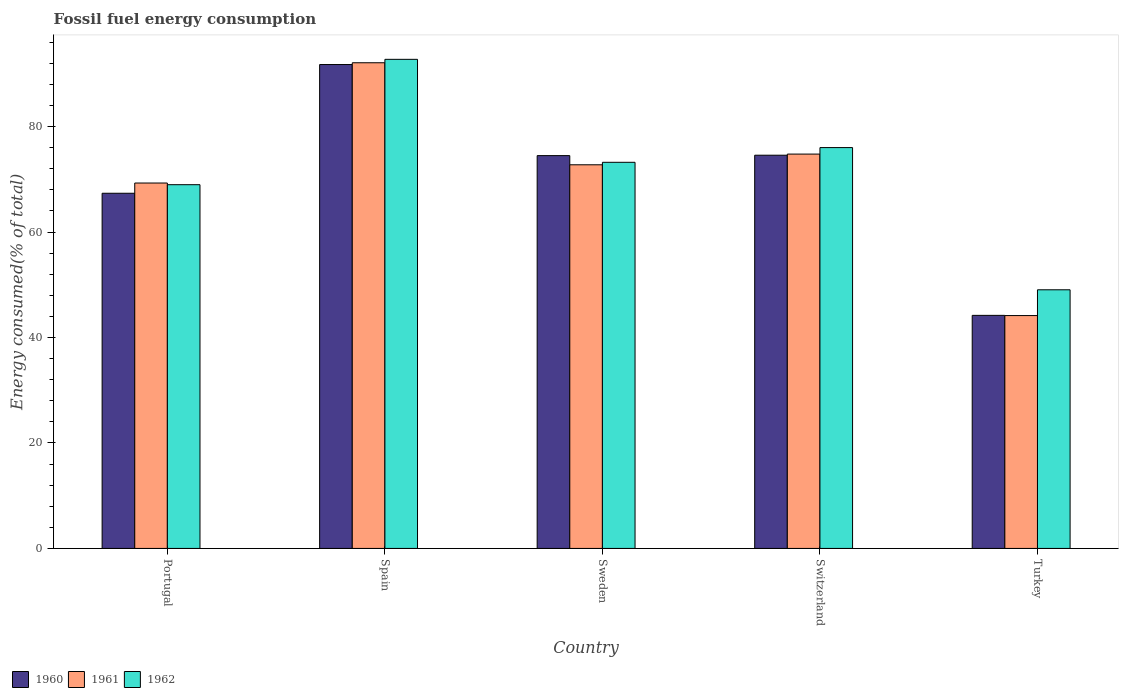Are the number of bars on each tick of the X-axis equal?
Provide a short and direct response. Yes. How many bars are there on the 4th tick from the left?
Keep it short and to the point. 3. What is the percentage of energy consumed in 1962 in Portugal?
Ensure brevity in your answer.  68.98. Across all countries, what is the maximum percentage of energy consumed in 1960?
Your answer should be compact. 91.77. Across all countries, what is the minimum percentage of energy consumed in 1960?
Offer a very short reply. 44.2. In which country was the percentage of energy consumed in 1961 maximum?
Your response must be concise. Spain. In which country was the percentage of energy consumed in 1960 minimum?
Offer a terse response. Turkey. What is the total percentage of energy consumed in 1961 in the graph?
Offer a very short reply. 353.1. What is the difference between the percentage of energy consumed in 1961 in Portugal and that in Spain?
Your answer should be compact. -22.81. What is the difference between the percentage of energy consumed in 1962 in Portugal and the percentage of energy consumed in 1960 in Turkey?
Ensure brevity in your answer.  24.78. What is the average percentage of energy consumed in 1960 per country?
Provide a short and direct response. 70.48. What is the difference between the percentage of energy consumed of/in 1961 and percentage of energy consumed of/in 1960 in Turkey?
Offer a very short reply. -0.04. What is the ratio of the percentage of energy consumed in 1962 in Spain to that in Turkey?
Make the answer very short. 1.89. Is the percentage of energy consumed in 1962 in Portugal less than that in Sweden?
Offer a very short reply. Yes. Is the difference between the percentage of energy consumed in 1961 in Portugal and Turkey greater than the difference between the percentage of energy consumed in 1960 in Portugal and Turkey?
Offer a very short reply. Yes. What is the difference between the highest and the second highest percentage of energy consumed in 1960?
Ensure brevity in your answer.  -17.19. What is the difference between the highest and the lowest percentage of energy consumed in 1962?
Provide a short and direct response. 43.7. In how many countries, is the percentage of energy consumed in 1961 greater than the average percentage of energy consumed in 1961 taken over all countries?
Make the answer very short. 3. How many bars are there?
Keep it short and to the point. 15. Are all the bars in the graph horizontal?
Offer a terse response. No. How many countries are there in the graph?
Your answer should be compact. 5. Are the values on the major ticks of Y-axis written in scientific E-notation?
Provide a succinct answer. No. Does the graph contain any zero values?
Make the answer very short. No. Where does the legend appear in the graph?
Provide a succinct answer. Bottom left. How are the legend labels stacked?
Give a very brief answer. Horizontal. What is the title of the graph?
Offer a terse response. Fossil fuel energy consumption. What is the label or title of the Y-axis?
Provide a short and direct response. Energy consumed(% of total). What is the Energy consumed(% of total) in 1960 in Portugal?
Make the answer very short. 67.36. What is the Energy consumed(% of total) of 1961 in Portugal?
Make the answer very short. 69.3. What is the Energy consumed(% of total) in 1962 in Portugal?
Give a very brief answer. 68.98. What is the Energy consumed(% of total) of 1960 in Spain?
Offer a very short reply. 91.77. What is the Energy consumed(% of total) of 1961 in Spain?
Offer a terse response. 92.1. What is the Energy consumed(% of total) of 1962 in Spain?
Ensure brevity in your answer.  92.75. What is the Energy consumed(% of total) in 1960 in Sweden?
Give a very brief answer. 74.49. What is the Energy consumed(% of total) of 1961 in Sweden?
Offer a very short reply. 72.75. What is the Energy consumed(% of total) in 1962 in Sweden?
Ensure brevity in your answer.  73.23. What is the Energy consumed(% of total) in 1960 in Switzerland?
Give a very brief answer. 74.57. What is the Energy consumed(% of total) of 1961 in Switzerland?
Keep it short and to the point. 74.78. What is the Energy consumed(% of total) in 1962 in Switzerland?
Your answer should be compact. 76.02. What is the Energy consumed(% of total) in 1960 in Turkey?
Ensure brevity in your answer.  44.2. What is the Energy consumed(% of total) of 1961 in Turkey?
Your answer should be very brief. 44.16. What is the Energy consumed(% of total) in 1962 in Turkey?
Offer a very short reply. 49.05. Across all countries, what is the maximum Energy consumed(% of total) of 1960?
Offer a very short reply. 91.77. Across all countries, what is the maximum Energy consumed(% of total) of 1961?
Provide a succinct answer. 92.1. Across all countries, what is the maximum Energy consumed(% of total) in 1962?
Your answer should be compact. 92.75. Across all countries, what is the minimum Energy consumed(% of total) of 1960?
Your response must be concise. 44.2. Across all countries, what is the minimum Energy consumed(% of total) in 1961?
Provide a succinct answer. 44.16. Across all countries, what is the minimum Energy consumed(% of total) in 1962?
Provide a succinct answer. 49.05. What is the total Energy consumed(% of total) in 1960 in the graph?
Give a very brief answer. 352.39. What is the total Energy consumed(% of total) in 1961 in the graph?
Your answer should be compact. 353.1. What is the total Energy consumed(% of total) in 1962 in the graph?
Provide a succinct answer. 360.03. What is the difference between the Energy consumed(% of total) in 1960 in Portugal and that in Spain?
Keep it short and to the point. -24.41. What is the difference between the Energy consumed(% of total) of 1961 in Portugal and that in Spain?
Your answer should be compact. -22.81. What is the difference between the Energy consumed(% of total) in 1962 in Portugal and that in Spain?
Your answer should be very brief. -23.77. What is the difference between the Energy consumed(% of total) in 1960 in Portugal and that in Sweden?
Make the answer very short. -7.14. What is the difference between the Energy consumed(% of total) in 1961 in Portugal and that in Sweden?
Your response must be concise. -3.46. What is the difference between the Energy consumed(% of total) in 1962 in Portugal and that in Sweden?
Your response must be concise. -4.25. What is the difference between the Energy consumed(% of total) of 1960 in Portugal and that in Switzerland?
Your response must be concise. -7.22. What is the difference between the Energy consumed(% of total) in 1961 in Portugal and that in Switzerland?
Your answer should be very brief. -5.49. What is the difference between the Energy consumed(% of total) of 1962 in Portugal and that in Switzerland?
Your response must be concise. -7.04. What is the difference between the Energy consumed(% of total) in 1960 in Portugal and that in Turkey?
Give a very brief answer. 23.16. What is the difference between the Energy consumed(% of total) in 1961 in Portugal and that in Turkey?
Provide a succinct answer. 25.14. What is the difference between the Energy consumed(% of total) in 1962 in Portugal and that in Turkey?
Give a very brief answer. 19.93. What is the difference between the Energy consumed(% of total) of 1960 in Spain and that in Sweden?
Your answer should be very brief. 17.27. What is the difference between the Energy consumed(% of total) of 1961 in Spain and that in Sweden?
Offer a very short reply. 19.35. What is the difference between the Energy consumed(% of total) in 1962 in Spain and that in Sweden?
Offer a terse response. 19.53. What is the difference between the Energy consumed(% of total) of 1960 in Spain and that in Switzerland?
Give a very brief answer. 17.19. What is the difference between the Energy consumed(% of total) of 1961 in Spain and that in Switzerland?
Your response must be concise. 17.32. What is the difference between the Energy consumed(% of total) of 1962 in Spain and that in Switzerland?
Your answer should be compact. 16.74. What is the difference between the Energy consumed(% of total) of 1960 in Spain and that in Turkey?
Give a very brief answer. 47.57. What is the difference between the Energy consumed(% of total) of 1961 in Spain and that in Turkey?
Make the answer very short. 47.95. What is the difference between the Energy consumed(% of total) of 1962 in Spain and that in Turkey?
Keep it short and to the point. 43.7. What is the difference between the Energy consumed(% of total) in 1960 in Sweden and that in Switzerland?
Your response must be concise. -0.08. What is the difference between the Energy consumed(% of total) in 1961 in Sweden and that in Switzerland?
Ensure brevity in your answer.  -2.03. What is the difference between the Energy consumed(% of total) in 1962 in Sweden and that in Switzerland?
Your answer should be compact. -2.79. What is the difference between the Energy consumed(% of total) in 1960 in Sweden and that in Turkey?
Your answer should be compact. 30.29. What is the difference between the Energy consumed(% of total) in 1961 in Sweden and that in Turkey?
Your response must be concise. 28.59. What is the difference between the Energy consumed(% of total) in 1962 in Sweden and that in Turkey?
Offer a very short reply. 24.18. What is the difference between the Energy consumed(% of total) in 1960 in Switzerland and that in Turkey?
Provide a succinct answer. 30.37. What is the difference between the Energy consumed(% of total) of 1961 in Switzerland and that in Turkey?
Your answer should be compact. 30.62. What is the difference between the Energy consumed(% of total) of 1962 in Switzerland and that in Turkey?
Your answer should be compact. 26.97. What is the difference between the Energy consumed(% of total) of 1960 in Portugal and the Energy consumed(% of total) of 1961 in Spain?
Keep it short and to the point. -24.75. What is the difference between the Energy consumed(% of total) of 1960 in Portugal and the Energy consumed(% of total) of 1962 in Spain?
Provide a short and direct response. -25.4. What is the difference between the Energy consumed(% of total) of 1961 in Portugal and the Energy consumed(% of total) of 1962 in Spain?
Offer a very short reply. -23.46. What is the difference between the Energy consumed(% of total) of 1960 in Portugal and the Energy consumed(% of total) of 1961 in Sweden?
Give a very brief answer. -5.4. What is the difference between the Energy consumed(% of total) in 1960 in Portugal and the Energy consumed(% of total) in 1962 in Sweden?
Keep it short and to the point. -5.87. What is the difference between the Energy consumed(% of total) in 1961 in Portugal and the Energy consumed(% of total) in 1962 in Sweden?
Your response must be concise. -3.93. What is the difference between the Energy consumed(% of total) in 1960 in Portugal and the Energy consumed(% of total) in 1961 in Switzerland?
Offer a very short reply. -7.43. What is the difference between the Energy consumed(% of total) of 1960 in Portugal and the Energy consumed(% of total) of 1962 in Switzerland?
Give a very brief answer. -8.66. What is the difference between the Energy consumed(% of total) of 1961 in Portugal and the Energy consumed(% of total) of 1962 in Switzerland?
Provide a succinct answer. -6.72. What is the difference between the Energy consumed(% of total) of 1960 in Portugal and the Energy consumed(% of total) of 1961 in Turkey?
Provide a succinct answer. 23.2. What is the difference between the Energy consumed(% of total) in 1960 in Portugal and the Energy consumed(% of total) in 1962 in Turkey?
Offer a terse response. 18.31. What is the difference between the Energy consumed(% of total) in 1961 in Portugal and the Energy consumed(% of total) in 1962 in Turkey?
Ensure brevity in your answer.  20.25. What is the difference between the Energy consumed(% of total) in 1960 in Spain and the Energy consumed(% of total) in 1961 in Sweden?
Your answer should be very brief. 19.01. What is the difference between the Energy consumed(% of total) in 1960 in Spain and the Energy consumed(% of total) in 1962 in Sweden?
Offer a very short reply. 18.54. What is the difference between the Energy consumed(% of total) of 1961 in Spain and the Energy consumed(% of total) of 1962 in Sweden?
Offer a terse response. 18.88. What is the difference between the Energy consumed(% of total) of 1960 in Spain and the Energy consumed(% of total) of 1961 in Switzerland?
Offer a very short reply. 16.98. What is the difference between the Energy consumed(% of total) in 1960 in Spain and the Energy consumed(% of total) in 1962 in Switzerland?
Give a very brief answer. 15.75. What is the difference between the Energy consumed(% of total) in 1961 in Spain and the Energy consumed(% of total) in 1962 in Switzerland?
Keep it short and to the point. 16.09. What is the difference between the Energy consumed(% of total) of 1960 in Spain and the Energy consumed(% of total) of 1961 in Turkey?
Offer a terse response. 47.61. What is the difference between the Energy consumed(% of total) of 1960 in Spain and the Energy consumed(% of total) of 1962 in Turkey?
Offer a terse response. 42.72. What is the difference between the Energy consumed(% of total) of 1961 in Spain and the Energy consumed(% of total) of 1962 in Turkey?
Make the answer very short. 43.05. What is the difference between the Energy consumed(% of total) in 1960 in Sweden and the Energy consumed(% of total) in 1961 in Switzerland?
Give a very brief answer. -0.29. What is the difference between the Energy consumed(% of total) in 1960 in Sweden and the Energy consumed(% of total) in 1962 in Switzerland?
Make the answer very short. -1.52. What is the difference between the Energy consumed(% of total) of 1961 in Sweden and the Energy consumed(% of total) of 1962 in Switzerland?
Give a very brief answer. -3.26. What is the difference between the Energy consumed(% of total) in 1960 in Sweden and the Energy consumed(% of total) in 1961 in Turkey?
Offer a terse response. 30.33. What is the difference between the Energy consumed(% of total) of 1960 in Sweden and the Energy consumed(% of total) of 1962 in Turkey?
Offer a very short reply. 25.44. What is the difference between the Energy consumed(% of total) in 1961 in Sweden and the Energy consumed(% of total) in 1962 in Turkey?
Keep it short and to the point. 23.7. What is the difference between the Energy consumed(% of total) of 1960 in Switzerland and the Energy consumed(% of total) of 1961 in Turkey?
Your response must be concise. 30.41. What is the difference between the Energy consumed(% of total) of 1960 in Switzerland and the Energy consumed(% of total) of 1962 in Turkey?
Give a very brief answer. 25.52. What is the difference between the Energy consumed(% of total) of 1961 in Switzerland and the Energy consumed(% of total) of 1962 in Turkey?
Give a very brief answer. 25.73. What is the average Energy consumed(% of total) of 1960 per country?
Give a very brief answer. 70.48. What is the average Energy consumed(% of total) in 1961 per country?
Ensure brevity in your answer.  70.62. What is the average Energy consumed(% of total) in 1962 per country?
Offer a terse response. 72.01. What is the difference between the Energy consumed(% of total) of 1960 and Energy consumed(% of total) of 1961 in Portugal?
Your answer should be compact. -1.94. What is the difference between the Energy consumed(% of total) in 1960 and Energy consumed(% of total) in 1962 in Portugal?
Provide a short and direct response. -1.62. What is the difference between the Energy consumed(% of total) in 1961 and Energy consumed(% of total) in 1962 in Portugal?
Offer a terse response. 0.32. What is the difference between the Energy consumed(% of total) in 1960 and Energy consumed(% of total) in 1961 in Spain?
Keep it short and to the point. -0.34. What is the difference between the Energy consumed(% of total) in 1960 and Energy consumed(% of total) in 1962 in Spain?
Give a very brief answer. -0.99. What is the difference between the Energy consumed(% of total) in 1961 and Energy consumed(% of total) in 1962 in Spain?
Make the answer very short. -0.65. What is the difference between the Energy consumed(% of total) of 1960 and Energy consumed(% of total) of 1961 in Sweden?
Make the answer very short. 1.74. What is the difference between the Energy consumed(% of total) in 1960 and Energy consumed(% of total) in 1962 in Sweden?
Make the answer very short. 1.27. What is the difference between the Energy consumed(% of total) of 1961 and Energy consumed(% of total) of 1962 in Sweden?
Your answer should be very brief. -0.47. What is the difference between the Energy consumed(% of total) in 1960 and Energy consumed(% of total) in 1961 in Switzerland?
Your answer should be very brief. -0.21. What is the difference between the Energy consumed(% of total) in 1960 and Energy consumed(% of total) in 1962 in Switzerland?
Offer a very short reply. -1.45. What is the difference between the Energy consumed(% of total) in 1961 and Energy consumed(% of total) in 1962 in Switzerland?
Ensure brevity in your answer.  -1.23. What is the difference between the Energy consumed(% of total) in 1960 and Energy consumed(% of total) in 1961 in Turkey?
Make the answer very short. 0.04. What is the difference between the Energy consumed(% of total) of 1960 and Energy consumed(% of total) of 1962 in Turkey?
Make the answer very short. -4.85. What is the difference between the Energy consumed(% of total) of 1961 and Energy consumed(% of total) of 1962 in Turkey?
Provide a succinct answer. -4.89. What is the ratio of the Energy consumed(% of total) in 1960 in Portugal to that in Spain?
Offer a terse response. 0.73. What is the ratio of the Energy consumed(% of total) in 1961 in Portugal to that in Spain?
Your answer should be compact. 0.75. What is the ratio of the Energy consumed(% of total) of 1962 in Portugal to that in Spain?
Your response must be concise. 0.74. What is the ratio of the Energy consumed(% of total) of 1960 in Portugal to that in Sweden?
Offer a very short reply. 0.9. What is the ratio of the Energy consumed(% of total) of 1961 in Portugal to that in Sweden?
Provide a succinct answer. 0.95. What is the ratio of the Energy consumed(% of total) of 1962 in Portugal to that in Sweden?
Offer a very short reply. 0.94. What is the ratio of the Energy consumed(% of total) in 1960 in Portugal to that in Switzerland?
Make the answer very short. 0.9. What is the ratio of the Energy consumed(% of total) of 1961 in Portugal to that in Switzerland?
Your answer should be compact. 0.93. What is the ratio of the Energy consumed(% of total) in 1962 in Portugal to that in Switzerland?
Your answer should be very brief. 0.91. What is the ratio of the Energy consumed(% of total) in 1960 in Portugal to that in Turkey?
Provide a succinct answer. 1.52. What is the ratio of the Energy consumed(% of total) in 1961 in Portugal to that in Turkey?
Offer a terse response. 1.57. What is the ratio of the Energy consumed(% of total) in 1962 in Portugal to that in Turkey?
Your answer should be compact. 1.41. What is the ratio of the Energy consumed(% of total) of 1960 in Spain to that in Sweden?
Your response must be concise. 1.23. What is the ratio of the Energy consumed(% of total) of 1961 in Spain to that in Sweden?
Provide a short and direct response. 1.27. What is the ratio of the Energy consumed(% of total) in 1962 in Spain to that in Sweden?
Your answer should be very brief. 1.27. What is the ratio of the Energy consumed(% of total) in 1960 in Spain to that in Switzerland?
Your response must be concise. 1.23. What is the ratio of the Energy consumed(% of total) of 1961 in Spain to that in Switzerland?
Ensure brevity in your answer.  1.23. What is the ratio of the Energy consumed(% of total) in 1962 in Spain to that in Switzerland?
Your answer should be very brief. 1.22. What is the ratio of the Energy consumed(% of total) in 1960 in Spain to that in Turkey?
Your response must be concise. 2.08. What is the ratio of the Energy consumed(% of total) of 1961 in Spain to that in Turkey?
Your answer should be very brief. 2.09. What is the ratio of the Energy consumed(% of total) in 1962 in Spain to that in Turkey?
Provide a succinct answer. 1.89. What is the ratio of the Energy consumed(% of total) in 1960 in Sweden to that in Switzerland?
Give a very brief answer. 1. What is the ratio of the Energy consumed(% of total) of 1961 in Sweden to that in Switzerland?
Give a very brief answer. 0.97. What is the ratio of the Energy consumed(% of total) in 1962 in Sweden to that in Switzerland?
Give a very brief answer. 0.96. What is the ratio of the Energy consumed(% of total) of 1960 in Sweden to that in Turkey?
Provide a succinct answer. 1.69. What is the ratio of the Energy consumed(% of total) of 1961 in Sweden to that in Turkey?
Provide a short and direct response. 1.65. What is the ratio of the Energy consumed(% of total) in 1962 in Sweden to that in Turkey?
Your response must be concise. 1.49. What is the ratio of the Energy consumed(% of total) in 1960 in Switzerland to that in Turkey?
Your answer should be compact. 1.69. What is the ratio of the Energy consumed(% of total) of 1961 in Switzerland to that in Turkey?
Your answer should be very brief. 1.69. What is the ratio of the Energy consumed(% of total) of 1962 in Switzerland to that in Turkey?
Keep it short and to the point. 1.55. What is the difference between the highest and the second highest Energy consumed(% of total) in 1960?
Your answer should be very brief. 17.19. What is the difference between the highest and the second highest Energy consumed(% of total) of 1961?
Offer a terse response. 17.32. What is the difference between the highest and the second highest Energy consumed(% of total) of 1962?
Keep it short and to the point. 16.74. What is the difference between the highest and the lowest Energy consumed(% of total) of 1960?
Your response must be concise. 47.57. What is the difference between the highest and the lowest Energy consumed(% of total) in 1961?
Ensure brevity in your answer.  47.95. What is the difference between the highest and the lowest Energy consumed(% of total) in 1962?
Your response must be concise. 43.7. 